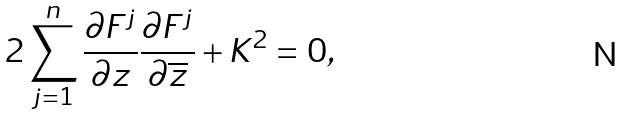<formula> <loc_0><loc_0><loc_500><loc_500>2 \sum _ { j = 1 } ^ { n } \frac { \partial F ^ { j } } { \partial z } \frac { \partial F ^ { j } } { \partial \overline { z } } + K ^ { 2 } = 0 ,</formula> 